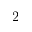Convert formula to latex. <formula><loc_0><loc_0><loc_500><loc_500>2</formula> 